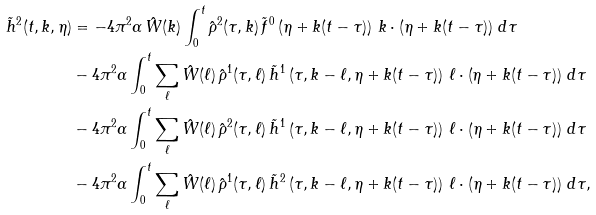Convert formula to latex. <formula><loc_0><loc_0><loc_500><loc_500>\tilde { h } ^ { 2 } ( t , k , \eta ) & = - 4 \pi ^ { 2 } \alpha \, \hat { W } ( k ) \int _ { 0 } ^ { t } \hat { \rho } ^ { 2 } ( \tau , k ) \, \tilde { f } ^ { 0 } \left ( \eta + k ( t - \tau ) \right ) \, k \cdot \left ( \eta + k ( t - \tau ) \right ) \, d \tau \\ & - 4 \pi ^ { 2 } \alpha \int _ { 0 } ^ { t } \sum _ { \ell } \hat { W } ( \ell ) \, \hat { \rho } ^ { 1 } ( \tau , \ell ) \, \tilde { h } ^ { 1 } \left ( \tau , k - \ell , \eta + k ( t - \tau ) \right ) \, \ell \cdot \left ( \eta + k ( t - \tau ) \right ) \, d \tau \\ & - 4 \pi ^ { 2 } \alpha \int _ { 0 } ^ { t } \sum _ { \ell } \hat { W } ( \ell ) \, \hat { \rho } ^ { 2 } ( \tau , \ell ) \, \tilde { h } ^ { 1 } \left ( \tau , k - \ell , \eta + k ( t - \tau ) \right ) \, \ell \cdot \left ( \eta + k ( t - \tau ) \right ) \, d \tau \\ & - 4 \pi ^ { 2 } \alpha \int _ { 0 } ^ { t } \sum _ { \ell } \hat { W } ( \ell ) \, \hat { \rho } ^ { 1 } ( \tau , \ell ) \, \tilde { h } ^ { 2 } \left ( \tau , k - \ell , \eta + k ( t - \tau ) \right ) \, \ell \cdot \left ( \eta + k ( t - \tau ) \right ) \, d \tau ,</formula> 